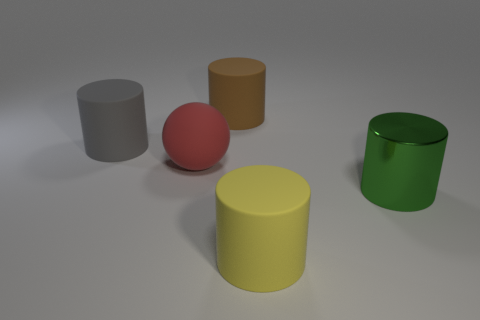Add 5 small brown metallic balls. How many objects exist? 10 Subtract all balls. How many objects are left? 4 Subtract all large matte things. Subtract all big blue metallic spheres. How many objects are left? 1 Add 3 gray rubber cylinders. How many gray rubber cylinders are left? 4 Add 5 big green shiny objects. How many big green shiny objects exist? 6 Subtract 1 brown cylinders. How many objects are left? 4 